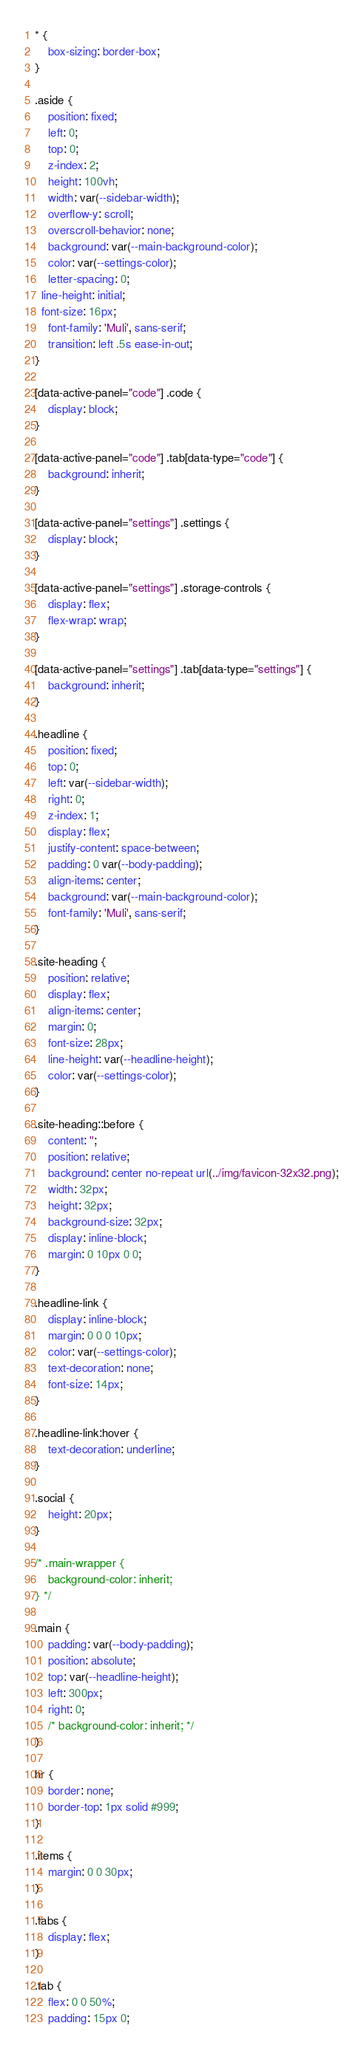<code> <loc_0><loc_0><loc_500><loc_500><_CSS_>* {
	box-sizing: border-box;
}

.aside {
	position: fixed;
	left: 0;
	top: 0;
	z-index: 2;
	height: 100vh;
	width: var(--sidebar-width);
	overflow-y: scroll;
	overscroll-behavior: none;
	background: var(--main-background-color);
	color: var(--settings-color);
	letter-spacing: 0;
  line-height: initial;
  font-size: 16px;
	font-family: 'Muli', sans-serif;
	transition: left .5s ease-in-out;
}

[data-active-panel="code"] .code {
	display: block;
}

[data-active-panel="code"] .tab[data-type="code"] {
	background: inherit;
}

[data-active-panel="settings"] .settings {
	display: block;
}

[data-active-panel="settings"] .storage-controls {
	display: flex;
	flex-wrap: wrap;
}

[data-active-panel="settings"] .tab[data-type="settings"] {
	background: inherit;
}

.headline {
	position: fixed;
	top: 0;
	left: var(--sidebar-width);
	right: 0;
	z-index: 1;
	display: flex;
	justify-content: space-between;
	padding: 0 var(--body-padding);
	align-items: center;
	background: var(--main-background-color);
	font-family: 'Muli', sans-serif;
}

.site-heading {
	position: relative;
	display: flex;
	align-items: center;
	margin: 0;
	font-size: 28px;
	line-height: var(--headline-height);
	color: var(--settings-color);
}

.site-heading::before {
	content: '';
	position: relative;
	background: center no-repeat url(../img/favicon-32x32.png);
	width: 32px;
	height: 32px;
	background-size: 32px;
	display: inline-block;
	margin: 0 10px 0 0;
}

.headline-link {
	display: inline-block;
	margin: 0 0 0 10px;
	color: var(--settings-color);
	text-decoration: none;
	font-size: 14px;
}

.headline-link:hover {
	text-decoration: underline;
}

.social {
	height: 20px;
}

/* .main-wrapper {
	background-color: inherit;
} */

.main {
	padding: var(--body-padding);
	position: absolute;
	top: var(--headline-height);
	left: 300px;
	right: 0;
	/* background-color: inherit; */
}

hr {
	border: none;
	border-top: 1px solid #999;
}

.items {
	margin: 0 0 30px;
}

.tabs {
	display: flex;
}

.tab {
	flex: 0 0 50%;
	padding: 15px 0;</code> 